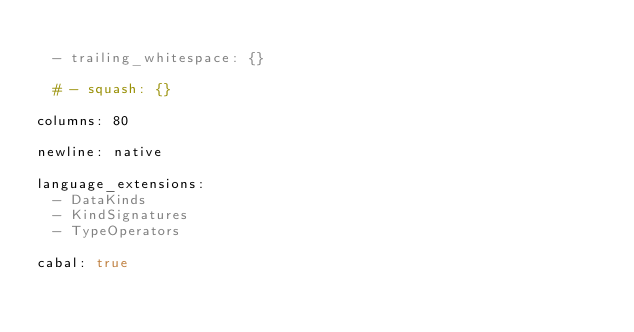<code> <loc_0><loc_0><loc_500><loc_500><_YAML_>
  - trailing_whitespace: {}

  # - squash: {}

columns: 80

newline: native

language_extensions:
  - DataKinds
  - KindSignatures
  - TypeOperators

cabal: true
</code> 